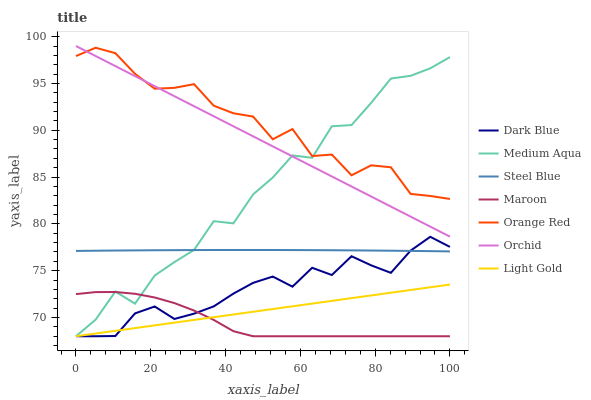Does Maroon have the minimum area under the curve?
Answer yes or no. Yes. Does Orange Red have the maximum area under the curve?
Answer yes or no. Yes. Does Dark Blue have the minimum area under the curve?
Answer yes or no. No. Does Dark Blue have the maximum area under the curve?
Answer yes or no. No. Is Light Gold the smoothest?
Answer yes or no. Yes. Is Medium Aqua the roughest?
Answer yes or no. Yes. Is Maroon the smoothest?
Answer yes or no. No. Is Maroon the roughest?
Answer yes or no. No. Does Maroon have the lowest value?
Answer yes or no. Yes. Does Orange Red have the lowest value?
Answer yes or no. No. Does Orchid have the highest value?
Answer yes or no. Yes. Does Dark Blue have the highest value?
Answer yes or no. No. Is Dark Blue less than Orchid?
Answer yes or no. Yes. Is Orchid greater than Maroon?
Answer yes or no. Yes. Does Orchid intersect Medium Aqua?
Answer yes or no. Yes. Is Orchid less than Medium Aqua?
Answer yes or no. No. Is Orchid greater than Medium Aqua?
Answer yes or no. No. Does Dark Blue intersect Orchid?
Answer yes or no. No. 